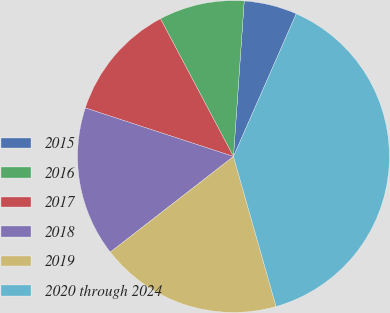Convert chart. <chart><loc_0><loc_0><loc_500><loc_500><pie_chart><fcel>2015<fcel>2016<fcel>2017<fcel>2018<fcel>2019<fcel>2020 through 2024<nl><fcel>5.5%<fcel>8.85%<fcel>12.2%<fcel>15.55%<fcel>18.9%<fcel>38.99%<nl></chart> 